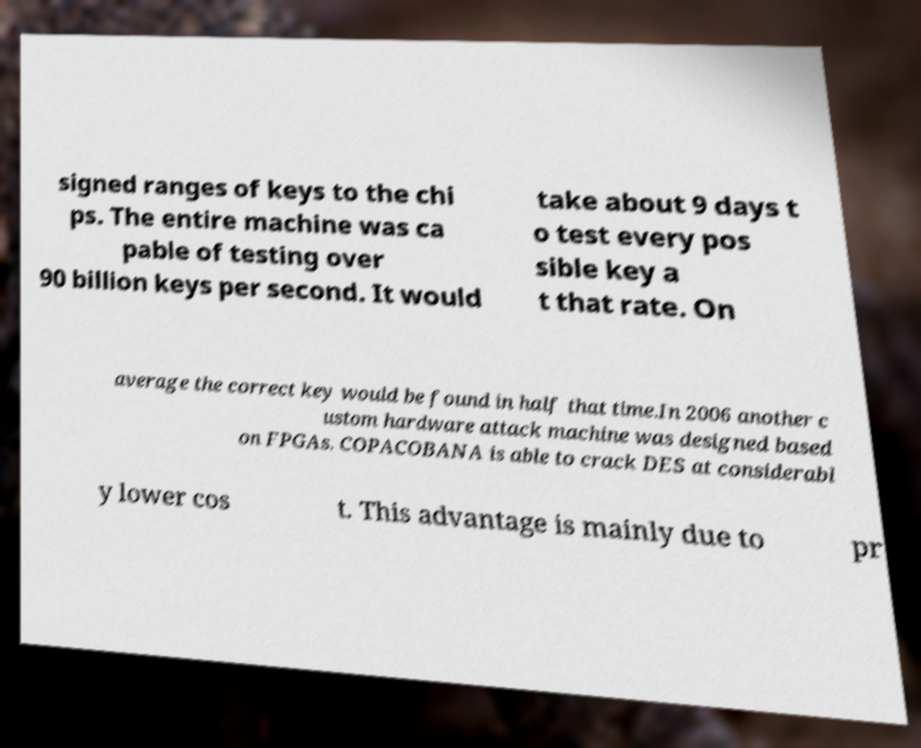There's text embedded in this image that I need extracted. Can you transcribe it verbatim? signed ranges of keys to the chi ps. The entire machine was ca pable of testing over 90 billion keys per second. It would take about 9 days t o test every pos sible key a t that rate. On average the correct key would be found in half that time.In 2006 another c ustom hardware attack machine was designed based on FPGAs. COPACOBANA is able to crack DES at considerabl y lower cos t. This advantage is mainly due to pr 